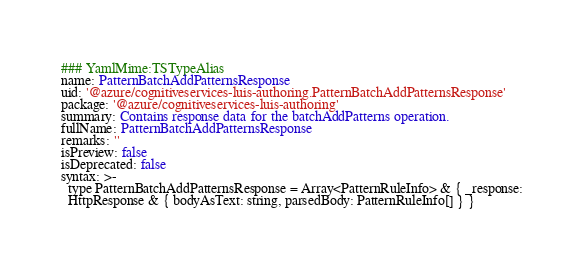Convert code to text. <code><loc_0><loc_0><loc_500><loc_500><_YAML_>### YamlMime:TSTypeAlias
name: PatternBatchAddPatternsResponse
uid: '@azure/cognitiveservices-luis-authoring.PatternBatchAddPatternsResponse'
package: '@azure/cognitiveservices-luis-authoring'
summary: Contains response data for the batchAddPatterns operation.
fullName: PatternBatchAddPatternsResponse
remarks: ''
isPreview: false
isDeprecated: false
syntax: >-
  type PatternBatchAddPatternsResponse = Array<PatternRuleInfo> & { _response:
  HttpResponse & { bodyAsText: string, parsedBody: PatternRuleInfo[] } }
</code> 